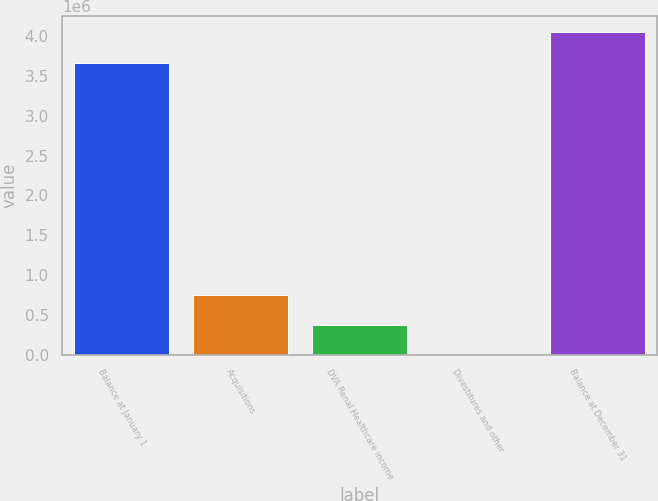Convert chart to OTSL. <chart><loc_0><loc_0><loc_500><loc_500><bar_chart><fcel>Balance at January 1<fcel>Acquisitions<fcel>DVA Renal Healthcare income<fcel>Divestitures and other<fcel>Balance at December 31<nl><fcel>3.66785e+06<fcel>754049<fcel>377314<fcel>578<fcel>4.04459e+06<nl></chart> 